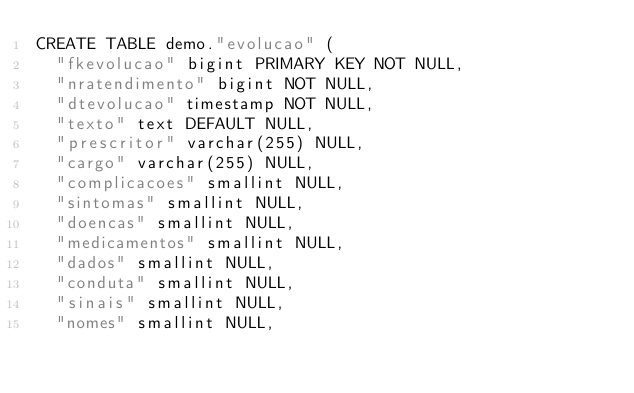Convert code to text. <code><loc_0><loc_0><loc_500><loc_500><_SQL_>CREATE TABLE demo."evolucao" (
  "fkevolucao" bigint PRIMARY KEY NOT NULL,
  "nratendimento" bigint NOT NULL,
  "dtevolucao" timestamp NOT NULL,
  "texto" text DEFAULT NULL,
  "prescritor" varchar(255) NULL,
  "cargo" varchar(255) NULL,
  "complicacoes" smallint NULL,
  "sintomas" smallint NULL,
  "doencas" smallint NULL,
  "medicamentos" smallint NULL,
  "dados" smallint NULL,
  "conduta" smallint NULL,
  "sinais" smallint NULL,
  "nomes" smallint NULL,</code> 